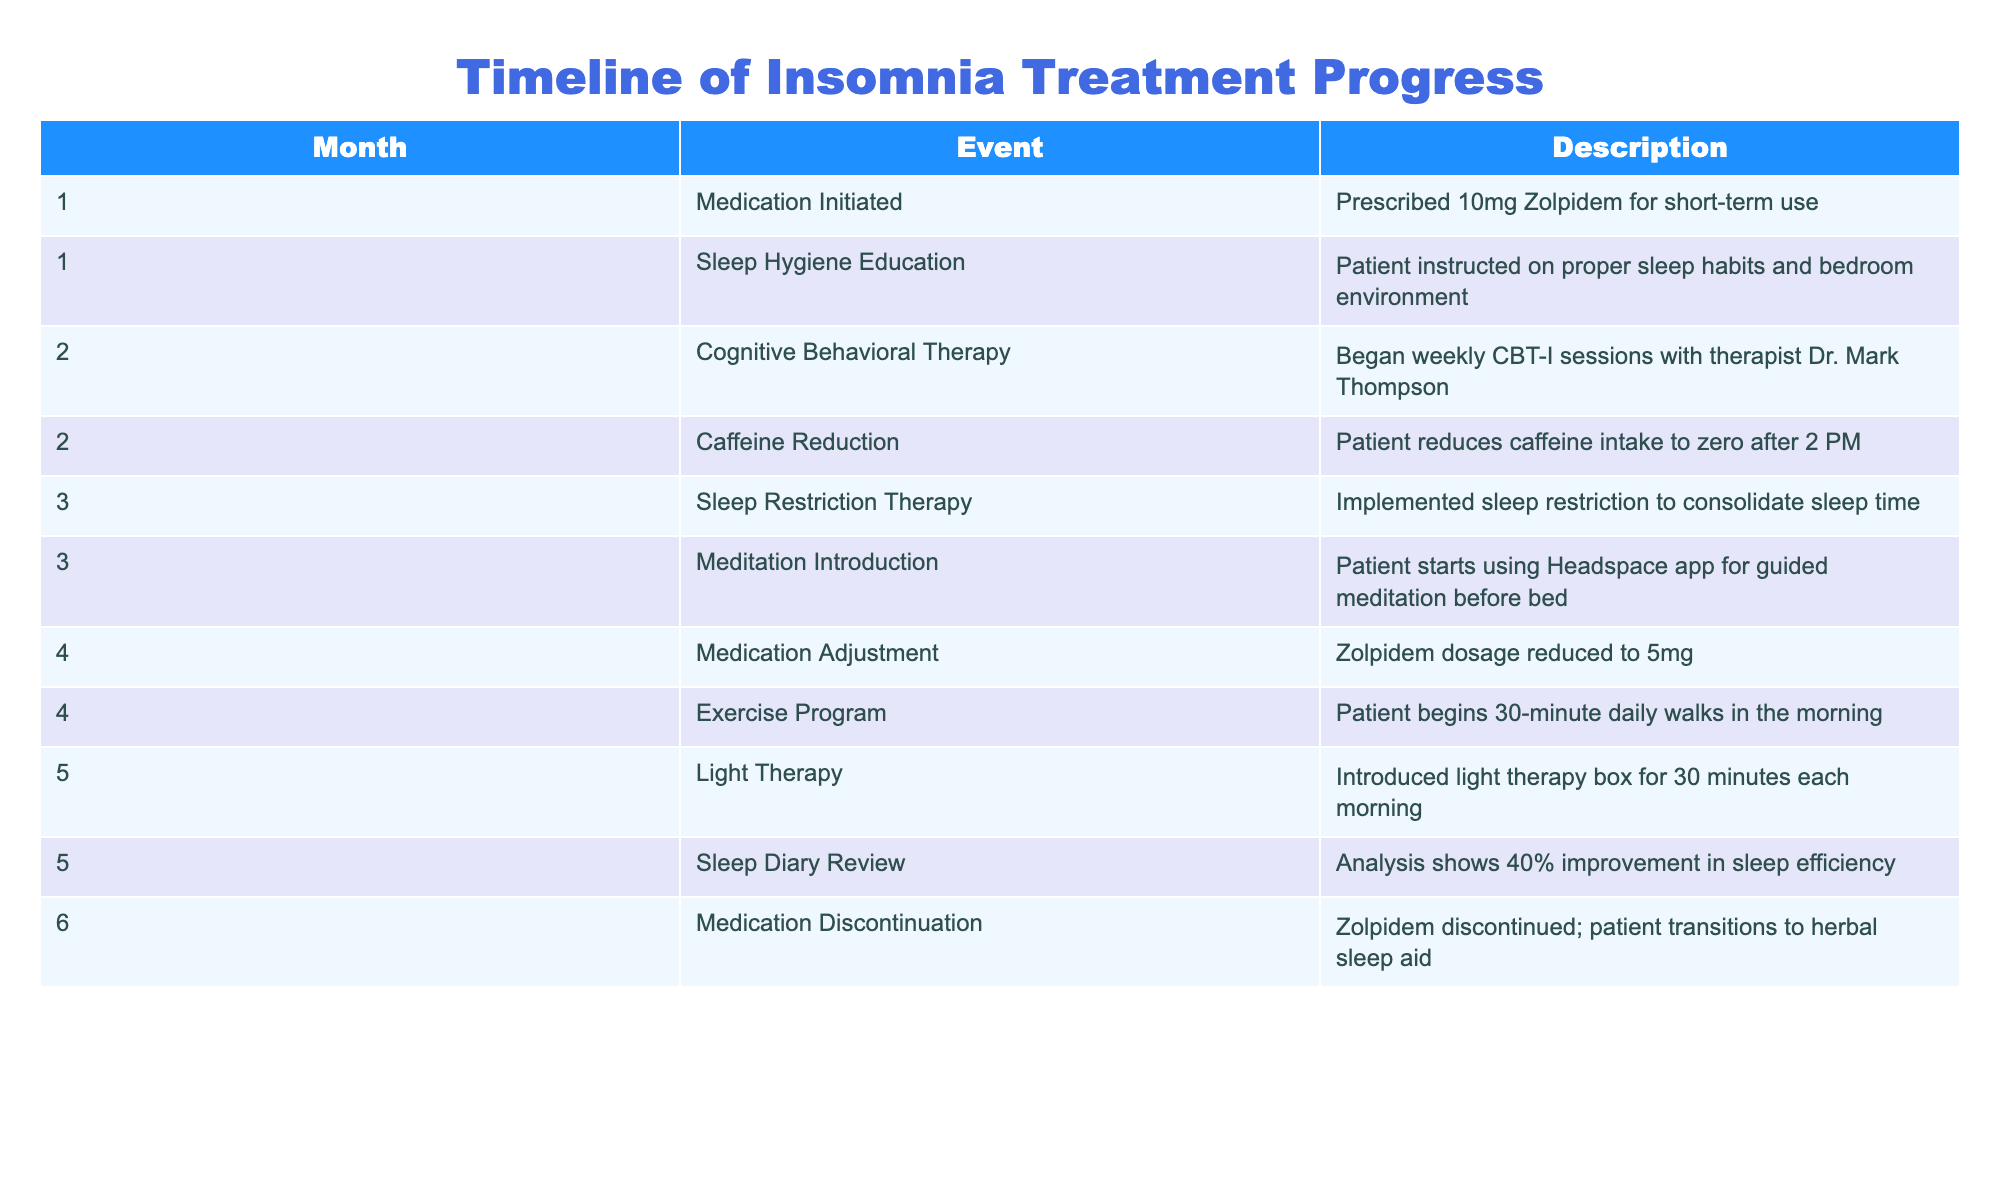What medication was prescribed in the first month? The table indicates that a medication was initiated in the first month, and specifically identifies Zolpidem at a dosage of 10mg.
Answer: Zolpidem 10mg How many therapy sessions did the patient have in the second month? According to the table, the patient began weekly Cognitive Behavioral Therapy sessions, which suggests one session per week. Since there are about four weeks in a month, the patient would have four sessions in total.
Answer: 4 Was the Zolpidem dosage reduced at any point? The table shows a medication adjustment in month four, where the Zolpidem dosage was reduced to 5mg, which confirms that a dosage reduction occurred.
Answer: Yes What was the improvement in sleep efficiency reported in month five? The table specifies that the analysis during the fifth month shows a 40% improvement in sleep efficiency, which provides the specific improvement figure directly.
Answer: 40% What lifestyle changes did the patient implement in conjunction with medication? To find this, we refer to multiple entries in the table. In months one, two, three, and four, the patient engaged in sleep hygiene education, caffeine reduction, sleep restriction therapy, and exercise program respectively. Thus, the overall lifestyle changes included these initiatives in combination with the medication adjustments.
Answer: Sleep hygiene education, caffeine reduction, sleep restriction therapy, and exercise program 